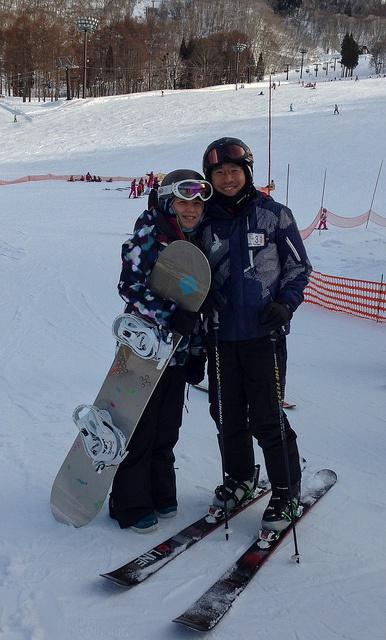Describe the objects in this image and their specific colors. I can see people in gray, black, and darkgray tones, people in gray, black, darkgray, and navy tones, snowboard in gray, black, and darkgray tones, skis in gray, black, and darkgray tones, and people in gray, lightgray, and darkgray tones in this image. 